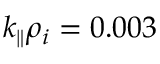<formula> <loc_0><loc_0><loc_500><loc_500>k _ { \| } \rho _ { i } = 0 . 0 0 3</formula> 